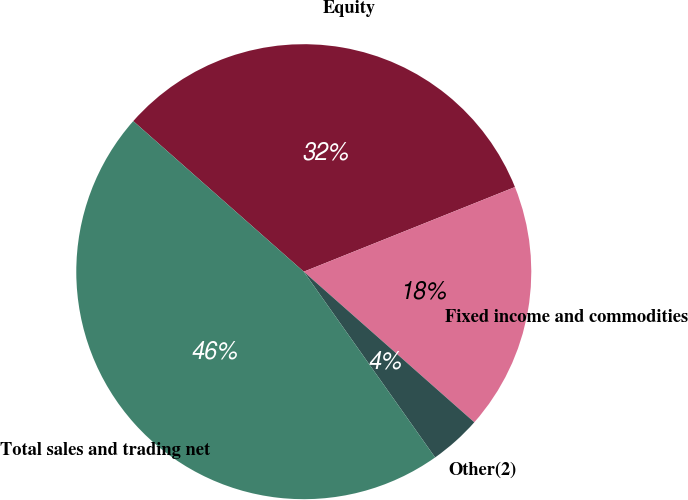Convert chart to OTSL. <chart><loc_0><loc_0><loc_500><loc_500><pie_chart><fcel>Equity<fcel>Fixed income and commodities<fcel>Other(2)<fcel>Total sales and trading net<nl><fcel>32.42%<fcel>17.58%<fcel>3.69%<fcel>46.31%<nl></chart> 